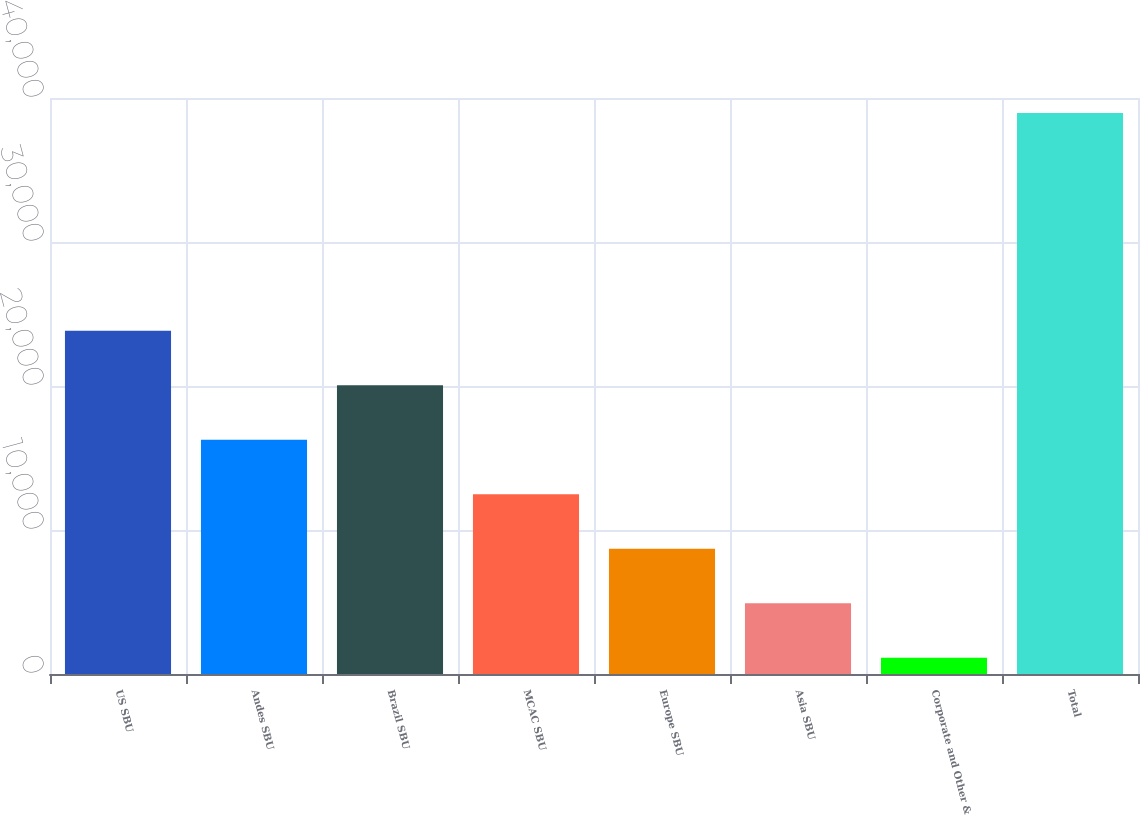<chart> <loc_0><loc_0><loc_500><loc_500><bar_chart><fcel>US SBU<fcel>Andes SBU<fcel>Brazil SBU<fcel>MCAC SBU<fcel>Europe SBU<fcel>Asia SBU<fcel>Corporate and Other &<fcel>Total<nl><fcel>23832.4<fcel>16265.6<fcel>20049<fcel>12482.2<fcel>8698.8<fcel>4915.4<fcel>1132<fcel>38966<nl></chart> 